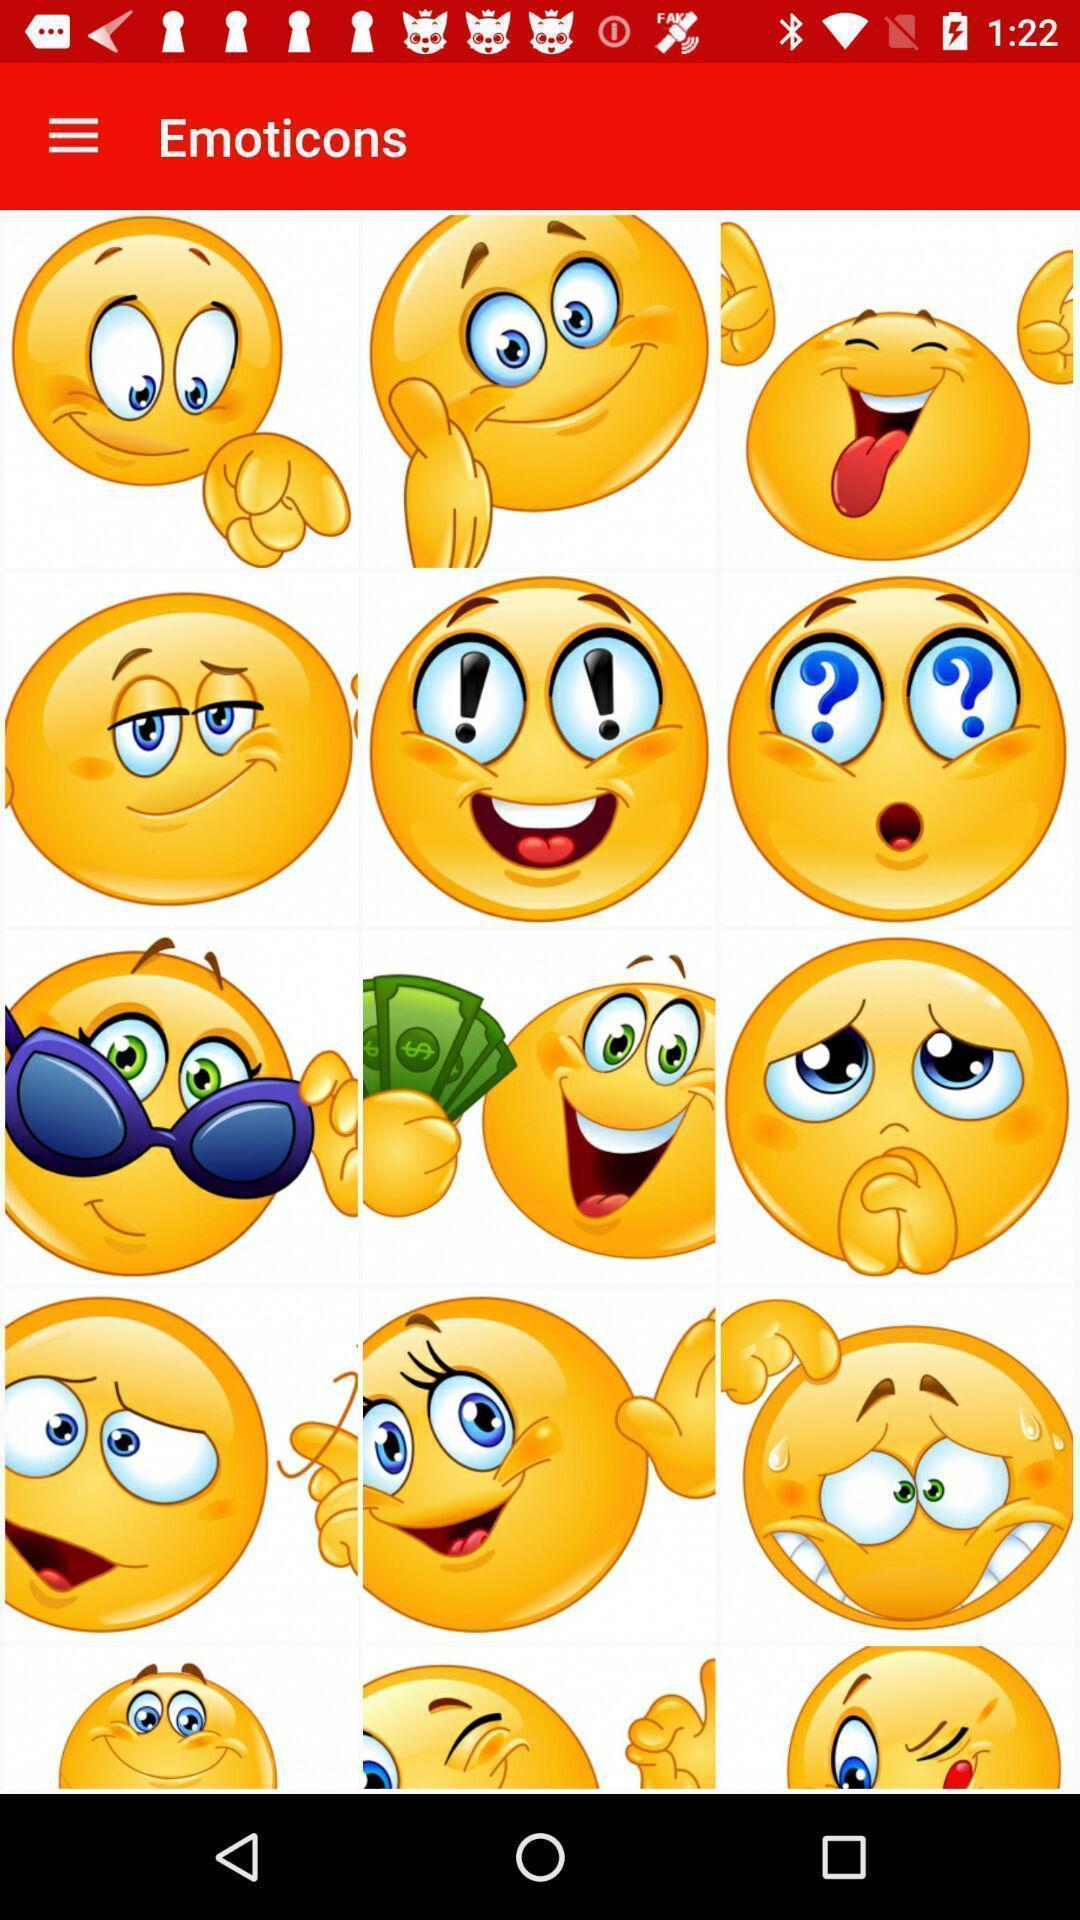Provide a textual representation of this image. Page showing different emotion emojis in emoji app. 